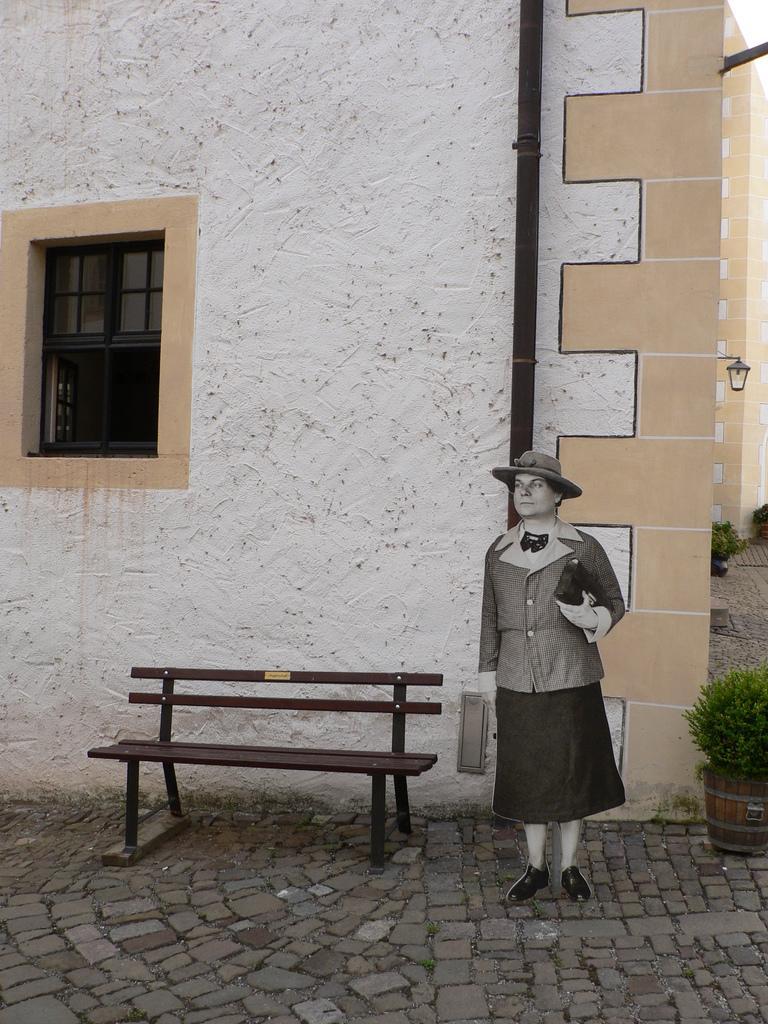Can you describe this image briefly? In this image I see a woman who is holding a thing in her hand and she is wearing a cap. In the background I see the wall, a window, a bench and few plants over here. 